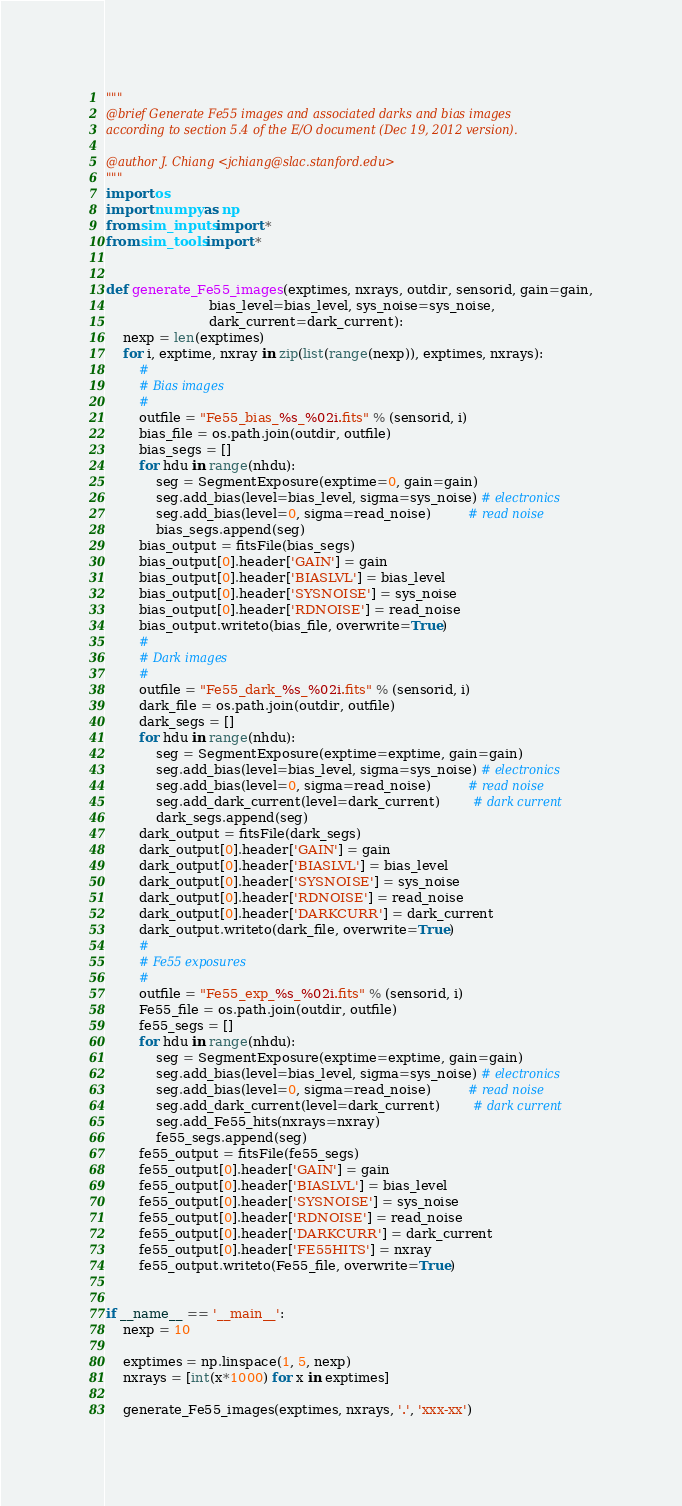<code> <loc_0><loc_0><loc_500><loc_500><_Python_>"""
@brief Generate Fe55 images and associated darks and bias images
according to section 5.4 of the E/O document (Dec 19, 2012 version).

@author J. Chiang <jchiang@slac.stanford.edu>
"""
import os
import numpy as np
from sim_inputs import *
from sim_tools import *


def generate_Fe55_images(exptimes, nxrays, outdir, sensorid, gain=gain,
                         bias_level=bias_level, sys_noise=sys_noise,
                         dark_current=dark_current):
    nexp = len(exptimes)
    for i, exptime, nxray in zip(list(range(nexp)), exptimes, nxrays):
        #
        # Bias images
        #
        outfile = "Fe55_bias_%s_%02i.fits" % (sensorid, i)
        bias_file = os.path.join(outdir, outfile)
        bias_segs = []
        for hdu in range(nhdu):
            seg = SegmentExposure(exptime=0, gain=gain)
            seg.add_bias(level=bias_level, sigma=sys_noise) # electronics
            seg.add_bias(level=0, sigma=read_noise)         # read noise
            bias_segs.append(seg)
        bias_output = fitsFile(bias_segs)
        bias_output[0].header['GAIN'] = gain
        bias_output[0].header['BIASLVL'] = bias_level
        bias_output[0].header['SYSNOISE'] = sys_noise
        bias_output[0].header['RDNOISE'] = read_noise
        bias_output.writeto(bias_file, overwrite=True)
        #
        # Dark images
        #
        outfile = "Fe55_dark_%s_%02i.fits" % (sensorid, i)
        dark_file = os.path.join(outdir, outfile)
        dark_segs = []
        for hdu in range(nhdu):
            seg = SegmentExposure(exptime=exptime, gain=gain)
            seg.add_bias(level=bias_level, sigma=sys_noise) # electronics
            seg.add_bias(level=0, sigma=read_noise)         # read noise
            seg.add_dark_current(level=dark_current)        # dark current
            dark_segs.append(seg)
        dark_output = fitsFile(dark_segs)
        dark_output[0].header['GAIN'] = gain
        dark_output[0].header['BIASLVL'] = bias_level
        dark_output[0].header['SYSNOISE'] = sys_noise
        dark_output[0].header['RDNOISE'] = read_noise
        dark_output[0].header['DARKCURR'] = dark_current
        dark_output.writeto(dark_file, overwrite=True)
        #
        # Fe55 exposures
        #
        outfile = "Fe55_exp_%s_%02i.fits" % (sensorid, i)
        Fe55_file = os.path.join(outdir, outfile)
        fe55_segs = []
        for hdu in range(nhdu):
            seg = SegmentExposure(exptime=exptime, gain=gain)
            seg.add_bias(level=bias_level, sigma=sys_noise) # electronics
            seg.add_bias(level=0, sigma=read_noise)         # read noise
            seg.add_dark_current(level=dark_current)        # dark current
            seg.add_Fe55_hits(nxrays=nxray)
            fe55_segs.append(seg)
        fe55_output = fitsFile(fe55_segs)
        fe55_output[0].header['GAIN'] = gain
        fe55_output[0].header['BIASLVL'] = bias_level
        fe55_output[0].header['SYSNOISE'] = sys_noise
        fe55_output[0].header['RDNOISE'] = read_noise
        fe55_output[0].header['DARKCURR'] = dark_current
        fe55_output[0].header['FE55HITS'] = nxray
        fe55_output.writeto(Fe55_file, overwrite=True)


if __name__ == '__main__':
    nexp = 10

    exptimes = np.linspace(1, 5, nexp)
    nxrays = [int(x*1000) for x in exptimes]

    generate_Fe55_images(exptimes, nxrays, '.', 'xxx-xx')
</code> 